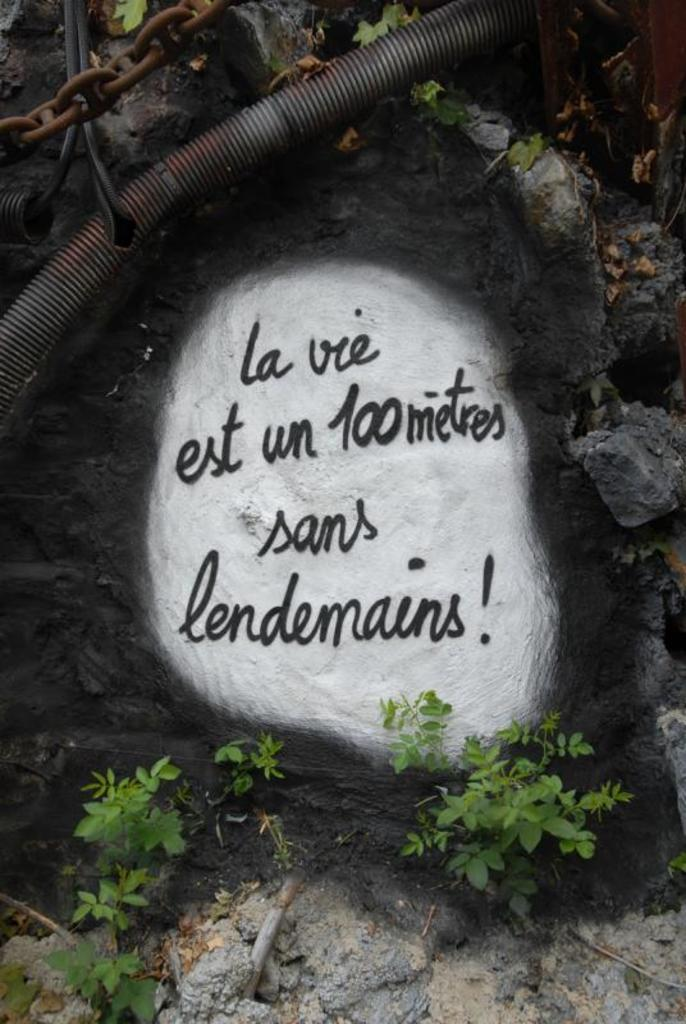What is written on in the image? There is text written on a stone in the image. What type of vegetation can be seen in the image? There are plants in the image. What type of material is the chain in the image made of? The chain in the image is made of iron. What type of wiring is present in the image? There are cables in the image. Can you describe the objects in the image? There are some objects in the image, but their specific details are not mentioned in the provided facts. How does the earthquake affect the stone with text in the image? There is no earthquake present in the image, so its effects cannot be determined. What type of furniture can be seen in the image? There is no furniture present in the image. 